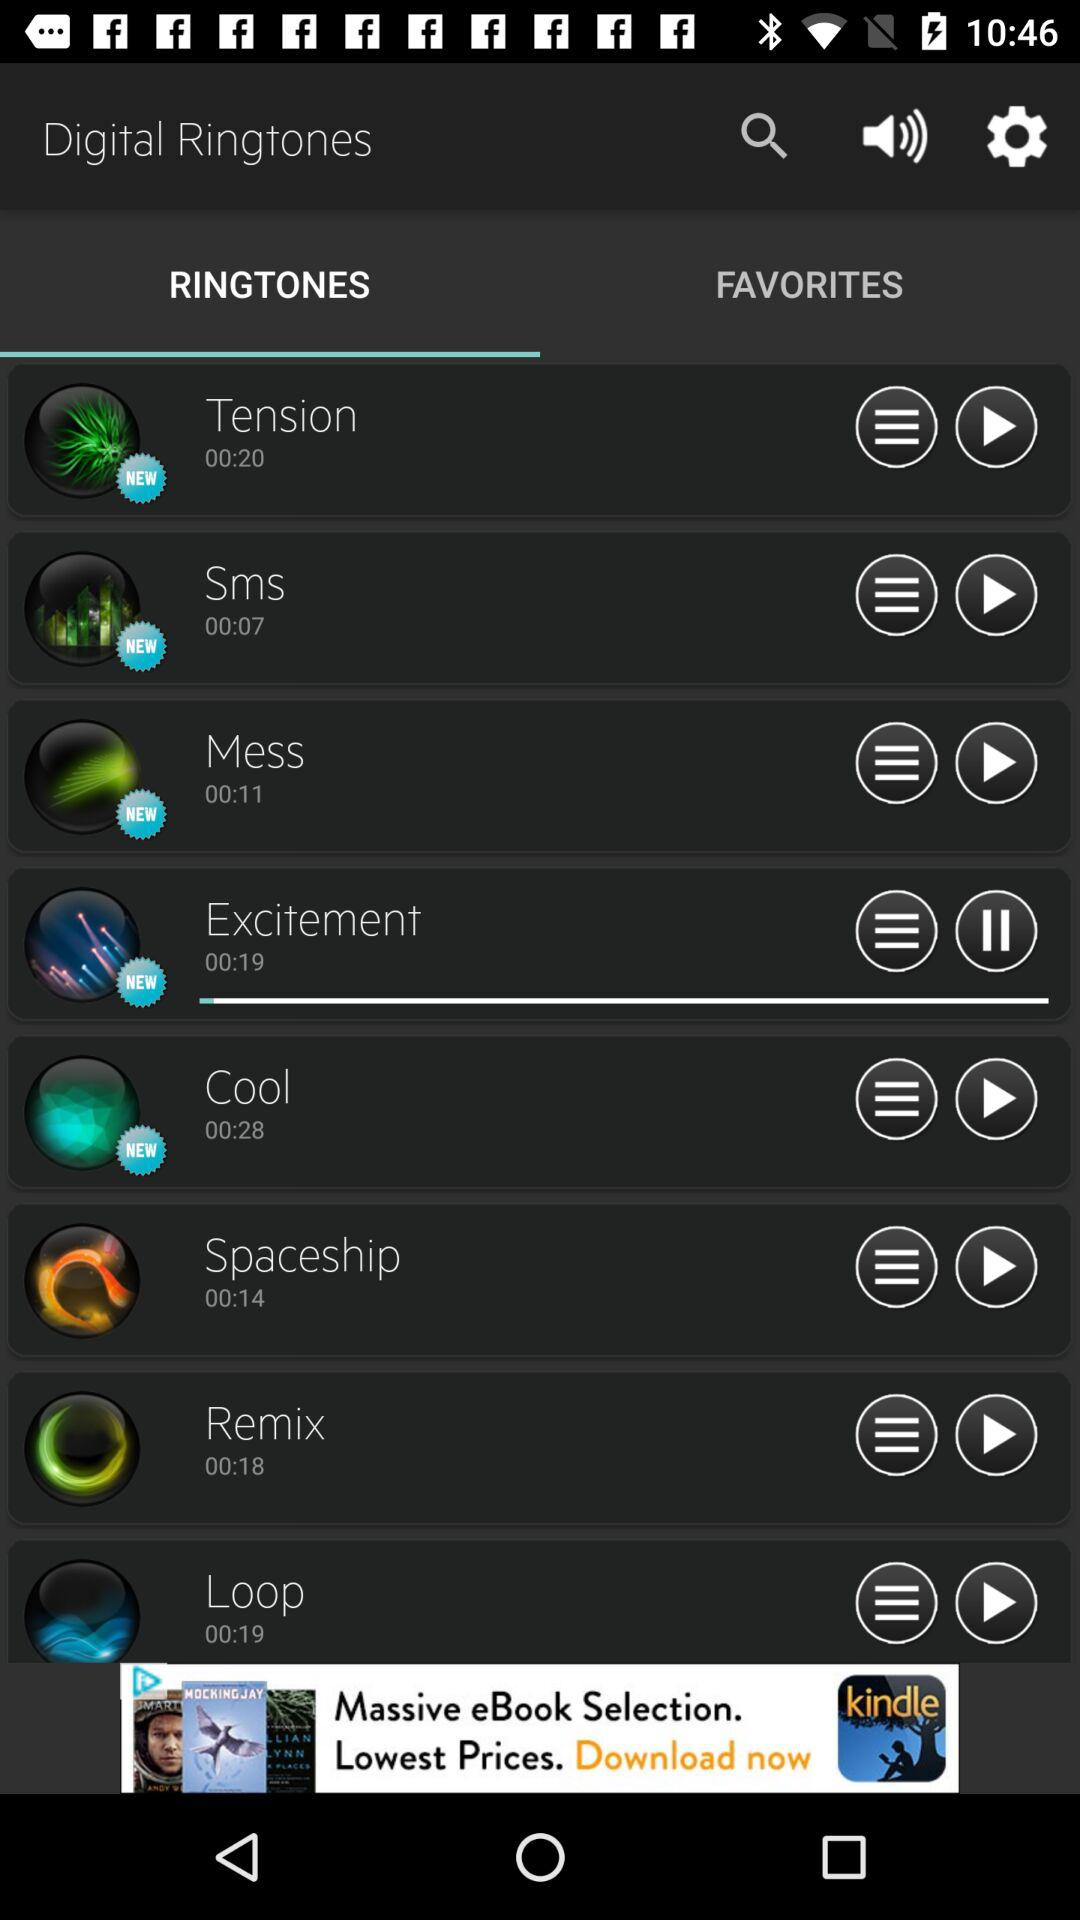Which audio is playing now? The audio that is playing now is "Excitement". 